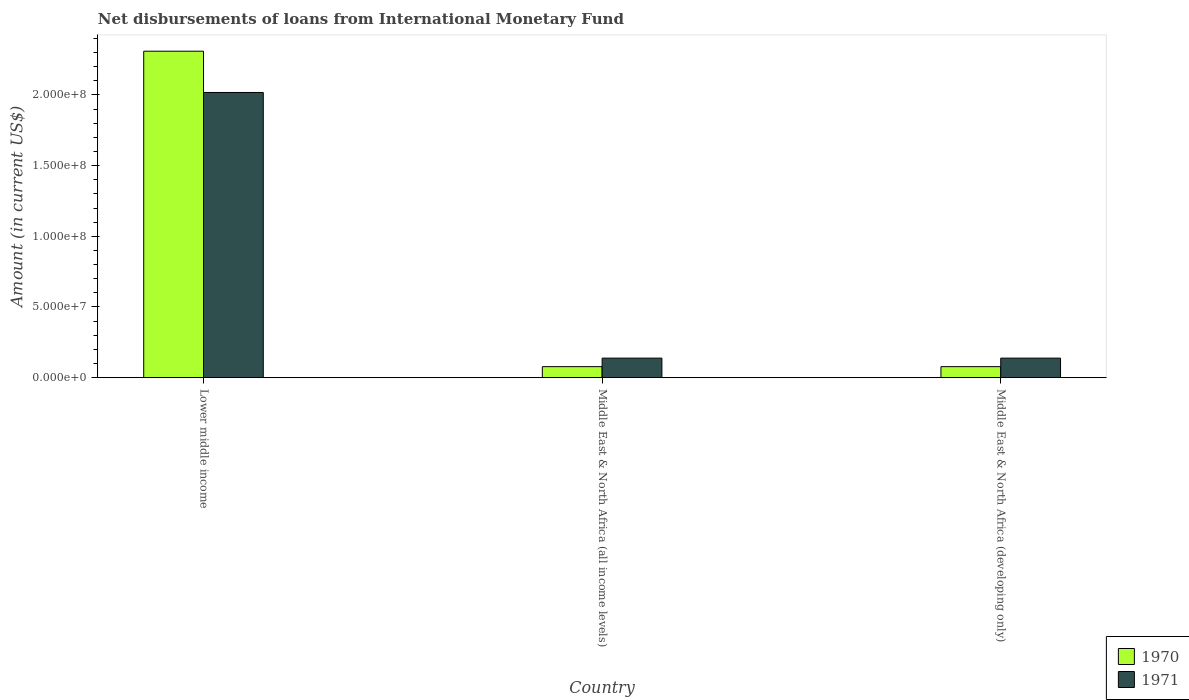How many groups of bars are there?
Your response must be concise. 3. Are the number of bars on each tick of the X-axis equal?
Ensure brevity in your answer.  Yes. How many bars are there on the 2nd tick from the left?
Provide a succinct answer. 2. How many bars are there on the 2nd tick from the right?
Offer a terse response. 2. What is the label of the 1st group of bars from the left?
Offer a terse response. Lower middle income. What is the amount of loans disbursed in 1970 in Middle East & North Africa (developing only)?
Provide a short and direct response. 7.79e+06. Across all countries, what is the maximum amount of loans disbursed in 1971?
Provide a short and direct response. 2.02e+08. Across all countries, what is the minimum amount of loans disbursed in 1970?
Provide a succinct answer. 7.79e+06. In which country was the amount of loans disbursed in 1971 maximum?
Offer a very short reply. Lower middle income. In which country was the amount of loans disbursed in 1970 minimum?
Make the answer very short. Middle East & North Africa (all income levels). What is the total amount of loans disbursed in 1970 in the graph?
Your answer should be very brief. 2.47e+08. What is the difference between the amount of loans disbursed in 1971 in Lower middle income and that in Middle East & North Africa (all income levels)?
Provide a short and direct response. 1.88e+08. What is the difference between the amount of loans disbursed in 1970 in Middle East & North Africa (developing only) and the amount of loans disbursed in 1971 in Lower middle income?
Make the answer very short. -1.94e+08. What is the average amount of loans disbursed in 1971 per country?
Provide a short and direct response. 7.65e+07. What is the difference between the amount of loans disbursed of/in 1970 and amount of loans disbursed of/in 1971 in Lower middle income?
Provide a succinct answer. 2.92e+07. In how many countries, is the amount of loans disbursed in 1970 greater than 170000000 US$?
Offer a terse response. 1. What is the ratio of the amount of loans disbursed in 1971 in Lower middle income to that in Middle East & North Africa (all income levels)?
Give a very brief answer. 14.6. Is the amount of loans disbursed in 1971 in Lower middle income less than that in Middle East & North Africa (developing only)?
Offer a terse response. No. What is the difference between the highest and the second highest amount of loans disbursed in 1971?
Ensure brevity in your answer.  1.88e+08. What is the difference between the highest and the lowest amount of loans disbursed in 1971?
Give a very brief answer. 1.88e+08. What does the 1st bar from the left in Lower middle income represents?
Keep it short and to the point. 1970. Are the values on the major ticks of Y-axis written in scientific E-notation?
Offer a very short reply. Yes. Does the graph contain any zero values?
Ensure brevity in your answer.  No. Does the graph contain grids?
Your answer should be compact. No. Where does the legend appear in the graph?
Provide a succinct answer. Bottom right. How are the legend labels stacked?
Your response must be concise. Vertical. What is the title of the graph?
Your response must be concise. Net disbursements of loans from International Monetary Fund. What is the label or title of the X-axis?
Keep it short and to the point. Country. What is the Amount (in current US$) in 1970 in Lower middle income?
Make the answer very short. 2.31e+08. What is the Amount (in current US$) in 1971 in Lower middle income?
Provide a short and direct response. 2.02e+08. What is the Amount (in current US$) in 1970 in Middle East & North Africa (all income levels)?
Give a very brief answer. 7.79e+06. What is the Amount (in current US$) in 1971 in Middle East & North Africa (all income levels)?
Your response must be concise. 1.38e+07. What is the Amount (in current US$) in 1970 in Middle East & North Africa (developing only)?
Keep it short and to the point. 7.79e+06. What is the Amount (in current US$) of 1971 in Middle East & North Africa (developing only)?
Provide a succinct answer. 1.38e+07. Across all countries, what is the maximum Amount (in current US$) in 1970?
Provide a succinct answer. 2.31e+08. Across all countries, what is the maximum Amount (in current US$) in 1971?
Make the answer very short. 2.02e+08. Across all countries, what is the minimum Amount (in current US$) in 1970?
Give a very brief answer. 7.79e+06. Across all countries, what is the minimum Amount (in current US$) in 1971?
Your answer should be very brief. 1.38e+07. What is the total Amount (in current US$) in 1970 in the graph?
Keep it short and to the point. 2.47e+08. What is the total Amount (in current US$) in 1971 in the graph?
Give a very brief answer. 2.29e+08. What is the difference between the Amount (in current US$) in 1970 in Lower middle income and that in Middle East & North Africa (all income levels)?
Offer a terse response. 2.23e+08. What is the difference between the Amount (in current US$) of 1971 in Lower middle income and that in Middle East & North Africa (all income levels)?
Offer a very short reply. 1.88e+08. What is the difference between the Amount (in current US$) of 1970 in Lower middle income and that in Middle East & North Africa (developing only)?
Provide a short and direct response. 2.23e+08. What is the difference between the Amount (in current US$) of 1971 in Lower middle income and that in Middle East & North Africa (developing only)?
Offer a very short reply. 1.88e+08. What is the difference between the Amount (in current US$) in 1970 in Middle East & North Africa (all income levels) and that in Middle East & North Africa (developing only)?
Your answer should be compact. 0. What is the difference between the Amount (in current US$) of 1970 in Lower middle income and the Amount (in current US$) of 1971 in Middle East & North Africa (all income levels)?
Offer a very short reply. 2.17e+08. What is the difference between the Amount (in current US$) of 1970 in Lower middle income and the Amount (in current US$) of 1971 in Middle East & North Africa (developing only)?
Ensure brevity in your answer.  2.17e+08. What is the difference between the Amount (in current US$) in 1970 in Middle East & North Africa (all income levels) and the Amount (in current US$) in 1971 in Middle East & North Africa (developing only)?
Provide a short and direct response. -6.03e+06. What is the average Amount (in current US$) of 1970 per country?
Keep it short and to the point. 8.22e+07. What is the average Amount (in current US$) in 1971 per country?
Ensure brevity in your answer.  7.65e+07. What is the difference between the Amount (in current US$) in 1970 and Amount (in current US$) in 1971 in Lower middle income?
Your answer should be compact. 2.92e+07. What is the difference between the Amount (in current US$) of 1970 and Amount (in current US$) of 1971 in Middle East & North Africa (all income levels)?
Keep it short and to the point. -6.03e+06. What is the difference between the Amount (in current US$) in 1970 and Amount (in current US$) in 1971 in Middle East & North Africa (developing only)?
Your response must be concise. -6.03e+06. What is the ratio of the Amount (in current US$) in 1970 in Lower middle income to that in Middle East & North Africa (all income levels)?
Provide a short and direct response. 29.63. What is the ratio of the Amount (in current US$) of 1971 in Lower middle income to that in Middle East & North Africa (all income levels)?
Keep it short and to the point. 14.6. What is the ratio of the Amount (in current US$) of 1970 in Lower middle income to that in Middle East & North Africa (developing only)?
Ensure brevity in your answer.  29.63. What is the ratio of the Amount (in current US$) of 1971 in Lower middle income to that in Middle East & North Africa (developing only)?
Ensure brevity in your answer.  14.6. What is the ratio of the Amount (in current US$) in 1970 in Middle East & North Africa (all income levels) to that in Middle East & North Africa (developing only)?
Ensure brevity in your answer.  1. What is the difference between the highest and the second highest Amount (in current US$) of 1970?
Offer a terse response. 2.23e+08. What is the difference between the highest and the second highest Amount (in current US$) in 1971?
Provide a short and direct response. 1.88e+08. What is the difference between the highest and the lowest Amount (in current US$) in 1970?
Keep it short and to the point. 2.23e+08. What is the difference between the highest and the lowest Amount (in current US$) of 1971?
Your answer should be very brief. 1.88e+08. 